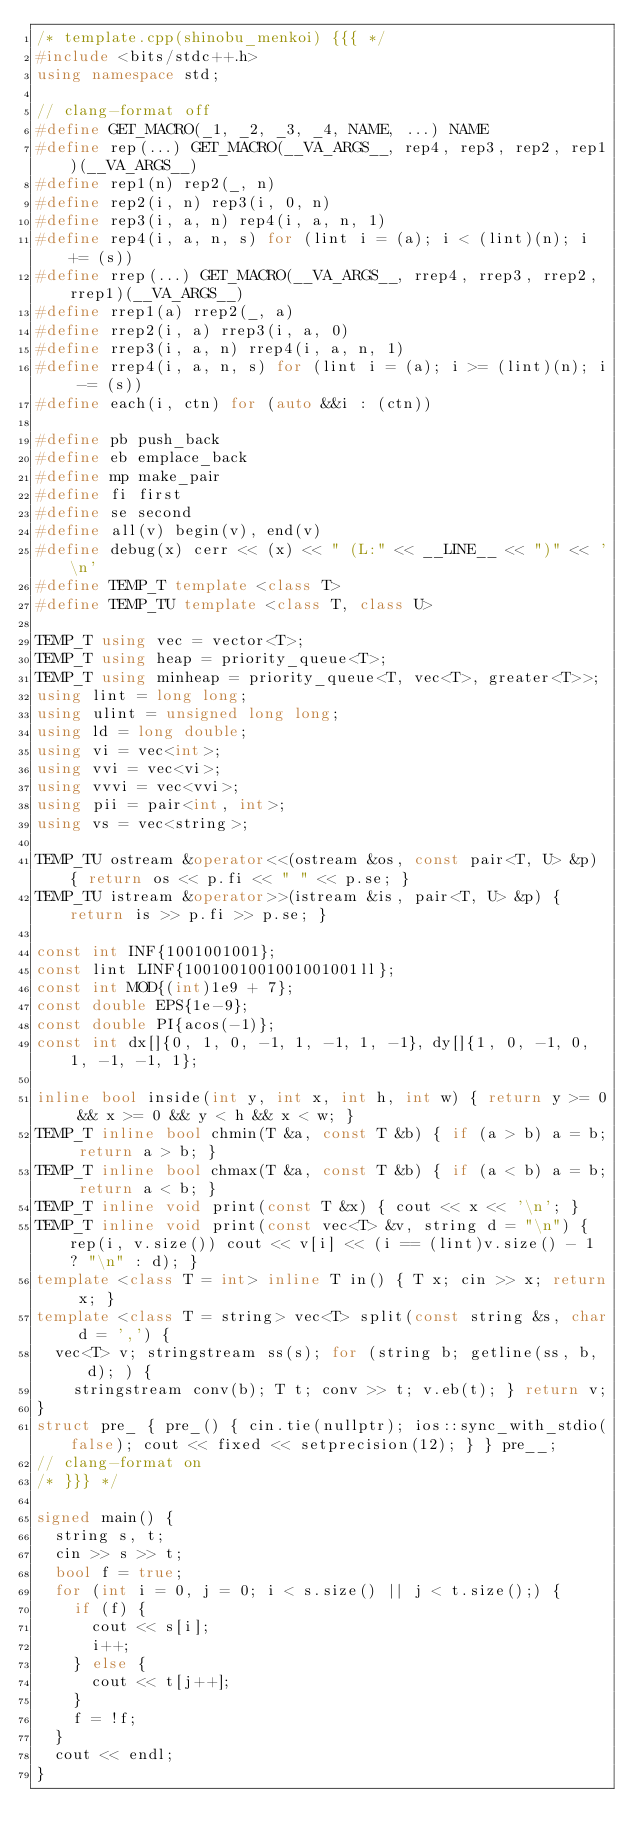Convert code to text. <code><loc_0><loc_0><loc_500><loc_500><_C++_>/* template.cpp(shinobu_menkoi) {{{ */
#include <bits/stdc++.h>
using namespace std;

// clang-format off
#define GET_MACRO(_1, _2, _3, _4, NAME, ...) NAME
#define rep(...) GET_MACRO(__VA_ARGS__, rep4, rep3, rep2, rep1)(__VA_ARGS__)
#define rep1(n) rep2(_, n)
#define rep2(i, n) rep3(i, 0, n)
#define rep3(i, a, n) rep4(i, a, n, 1)
#define rep4(i, a, n, s) for (lint i = (a); i < (lint)(n); i += (s))
#define rrep(...) GET_MACRO(__VA_ARGS__, rrep4, rrep3, rrep2, rrep1)(__VA_ARGS__)
#define rrep1(a) rrep2(_, a)
#define rrep2(i, a) rrep3(i, a, 0)
#define rrep3(i, a, n) rrep4(i, a, n, 1)
#define rrep4(i, a, n, s) for (lint i = (a); i >= (lint)(n); i -= (s))
#define each(i, ctn) for (auto &&i : (ctn))

#define pb push_back
#define eb emplace_back
#define mp make_pair
#define fi first
#define se second
#define all(v) begin(v), end(v)
#define debug(x) cerr << (x) << " (L:" << __LINE__ << ")" << '\n'
#define TEMP_T template <class T>
#define TEMP_TU template <class T, class U>

TEMP_T using vec = vector<T>;
TEMP_T using heap = priority_queue<T>;
TEMP_T using minheap = priority_queue<T, vec<T>, greater<T>>;
using lint = long long;
using ulint = unsigned long long;
using ld = long double;
using vi = vec<int>;
using vvi = vec<vi>;
using vvvi = vec<vvi>;
using pii = pair<int, int>;
using vs = vec<string>;

TEMP_TU ostream &operator<<(ostream &os, const pair<T, U> &p) { return os << p.fi << " " << p.se; }
TEMP_TU istream &operator>>(istream &is, pair<T, U> &p) { return is >> p.fi >> p.se; }

const int INF{1001001001};
const lint LINF{1001001001001001001ll};
const int MOD{(int)1e9 + 7};
const double EPS{1e-9};
const double PI{acos(-1)};
const int dx[]{0, 1, 0, -1, 1, -1, 1, -1}, dy[]{1, 0, -1, 0, 1, -1, -1, 1};

inline bool inside(int y, int x, int h, int w) { return y >= 0 && x >= 0 && y < h && x < w; }
TEMP_T inline bool chmin(T &a, const T &b) { if (a > b) a = b; return a > b; }
TEMP_T inline bool chmax(T &a, const T &b) { if (a < b) a = b; return a < b; }
TEMP_T inline void print(const T &x) { cout << x << '\n'; }
TEMP_T inline void print(const vec<T> &v, string d = "\n") { rep(i, v.size()) cout << v[i] << (i == (lint)v.size() - 1 ? "\n" : d); }
template <class T = int> inline T in() { T x; cin >> x; return x; }
template <class T = string> vec<T> split(const string &s, char d = ',') {
  vec<T> v; stringstream ss(s); for (string b; getline(ss, b, d); ) {
    stringstream conv(b); T t; conv >> t; v.eb(t); } return v;
}
struct pre_ { pre_() { cin.tie(nullptr); ios::sync_with_stdio(false); cout << fixed << setprecision(12); } } pre__;
// clang-format on
/* }}} */

signed main() {
  string s, t;
  cin >> s >> t;
  bool f = true;
  for (int i = 0, j = 0; i < s.size() || j < t.size();) {
    if (f) {
      cout << s[i];
      i++;
    } else {
      cout << t[j++];
    }
    f = !f;
  }
  cout << endl;
}
</code> 